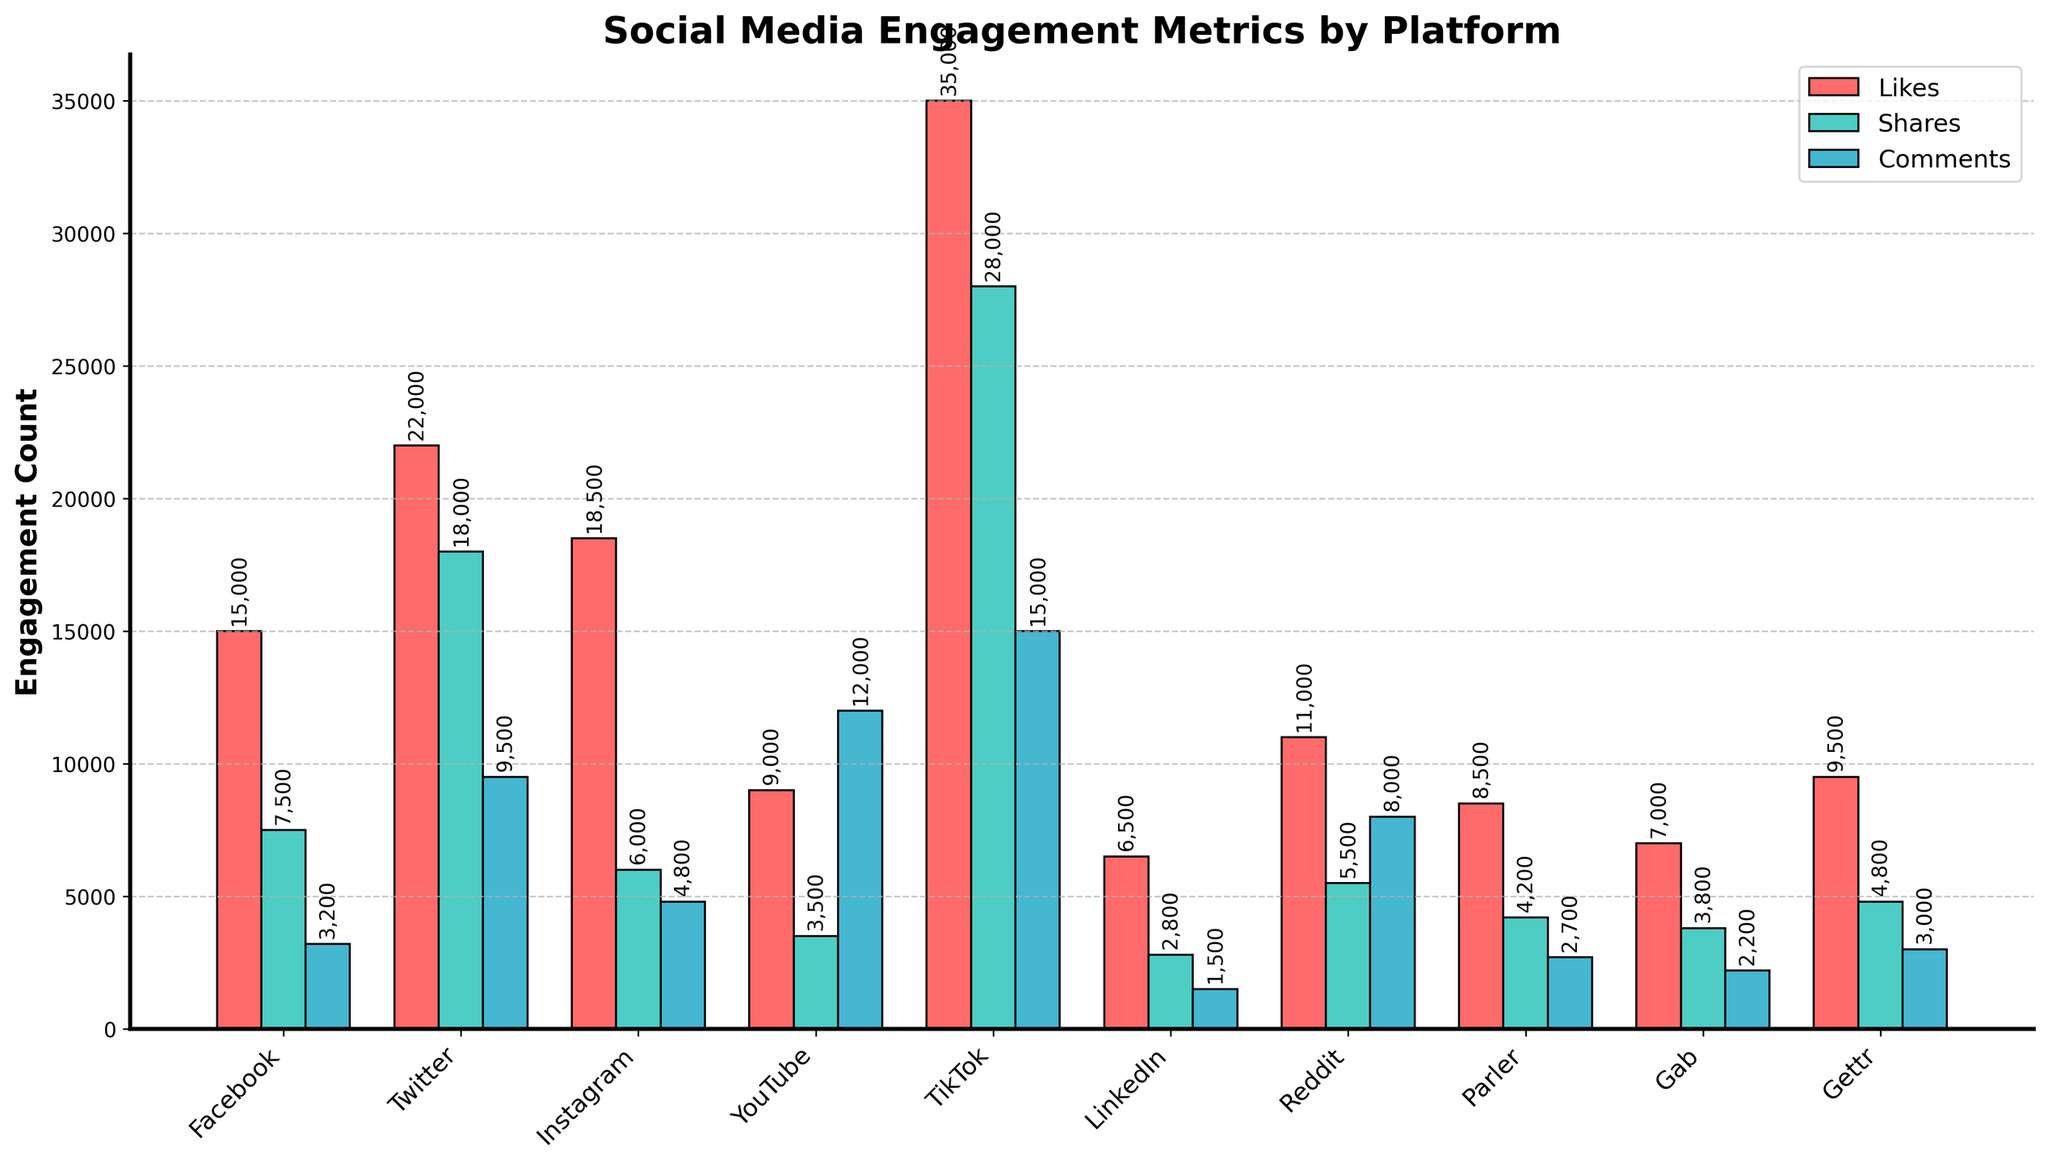What platform has the highest number of likes? Look at the height of the bars corresponding to likes across all platforms and identify the tallest one. TikTok has the highest bar when it comes to likes.
Answer: TikTok Which platform has more shares: Facebook or Instagram? Compare the heights of the bars for shares between Facebook and Instagram. The height of the bar for Instagram is lower than that of Facebook.
Answer: Facebook What is the difference in the number of comments between YouTube and Reddit? Check the bars for comments for both YouTube and Reddit, find their respective heights, and subtract the smaller number from the larger number. YouTube has 12,000 comments and Reddit has 8,000. 12,000 - 8,000 = 4,000.
Answer: 4,000 Which engagement metric has the highest count on Twitter? Look at the heights of the three bars (likes, shares, comments) for Twitter. The tallest bar corresponds to shares.
Answer: Shares What is the average number of likes across all platforms? Sum all the likes counts and divide by the number of platforms: (15000 + 22000 + 18500 + 9000 + 35000 + 6500 + 11000 + 8500 + 7000 + 9500) / 10 = 1,395,000 / 10 = 13,950.
Answer: 13,950 Which platform has the fewest comments? Compare the heights of the 'Comments' bars across all platforms and find the lowest one. LinkedIn has the shortest bar with 1,500 comments.
Answer: LinkedIn What is the combined total of shares for YouTube and TikTok? Identify the heights of the bars for shares on both YouTube and TikTok and then add them together: 3,500 (YouTube) + 28,000 (TikTok) = 31,500.
Answer: 31,500 Which two platforms have the least difference in likes counts? Subtract the likes counts for pairs of platforms to find the pair with the smallest difference: Example pair - Parler (8,500) and Gab (7,000). The difference is 1,500, which is smaller than other differences from pairs like Facebook and Twitter.
Answer: Parler and Gab Compare the number of likes on Instagram and the number of shares on LinkedIn. Which one is higher? Compare the heights of the likes bar for Instagram and the shares bar for LinkedIn. Likes on Instagram is much higher (18,500 vs. 2,800).
Answer: Instagram What is the sum of comments for platforms Twitter, Facebook, and Instagram? Sum all the heights of the ‘Comments’ bars for Twitter, Facebook, and Instagram: 9,500 (Twitter) + 3,200 (Facebook) + 4,800 (Instagram) = 17,500.
Answer: 17,500 